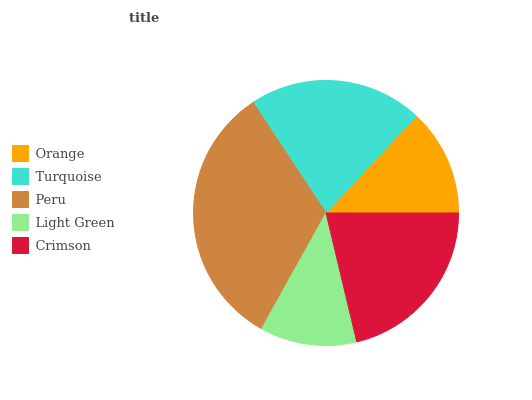Is Light Green the minimum?
Answer yes or no. Yes. Is Peru the maximum?
Answer yes or no. Yes. Is Turquoise the minimum?
Answer yes or no. No. Is Turquoise the maximum?
Answer yes or no. No. Is Turquoise greater than Orange?
Answer yes or no. Yes. Is Orange less than Turquoise?
Answer yes or no. Yes. Is Orange greater than Turquoise?
Answer yes or no. No. Is Turquoise less than Orange?
Answer yes or no. No. Is Turquoise the high median?
Answer yes or no. Yes. Is Turquoise the low median?
Answer yes or no. Yes. Is Crimson the high median?
Answer yes or no. No. Is Crimson the low median?
Answer yes or no. No. 